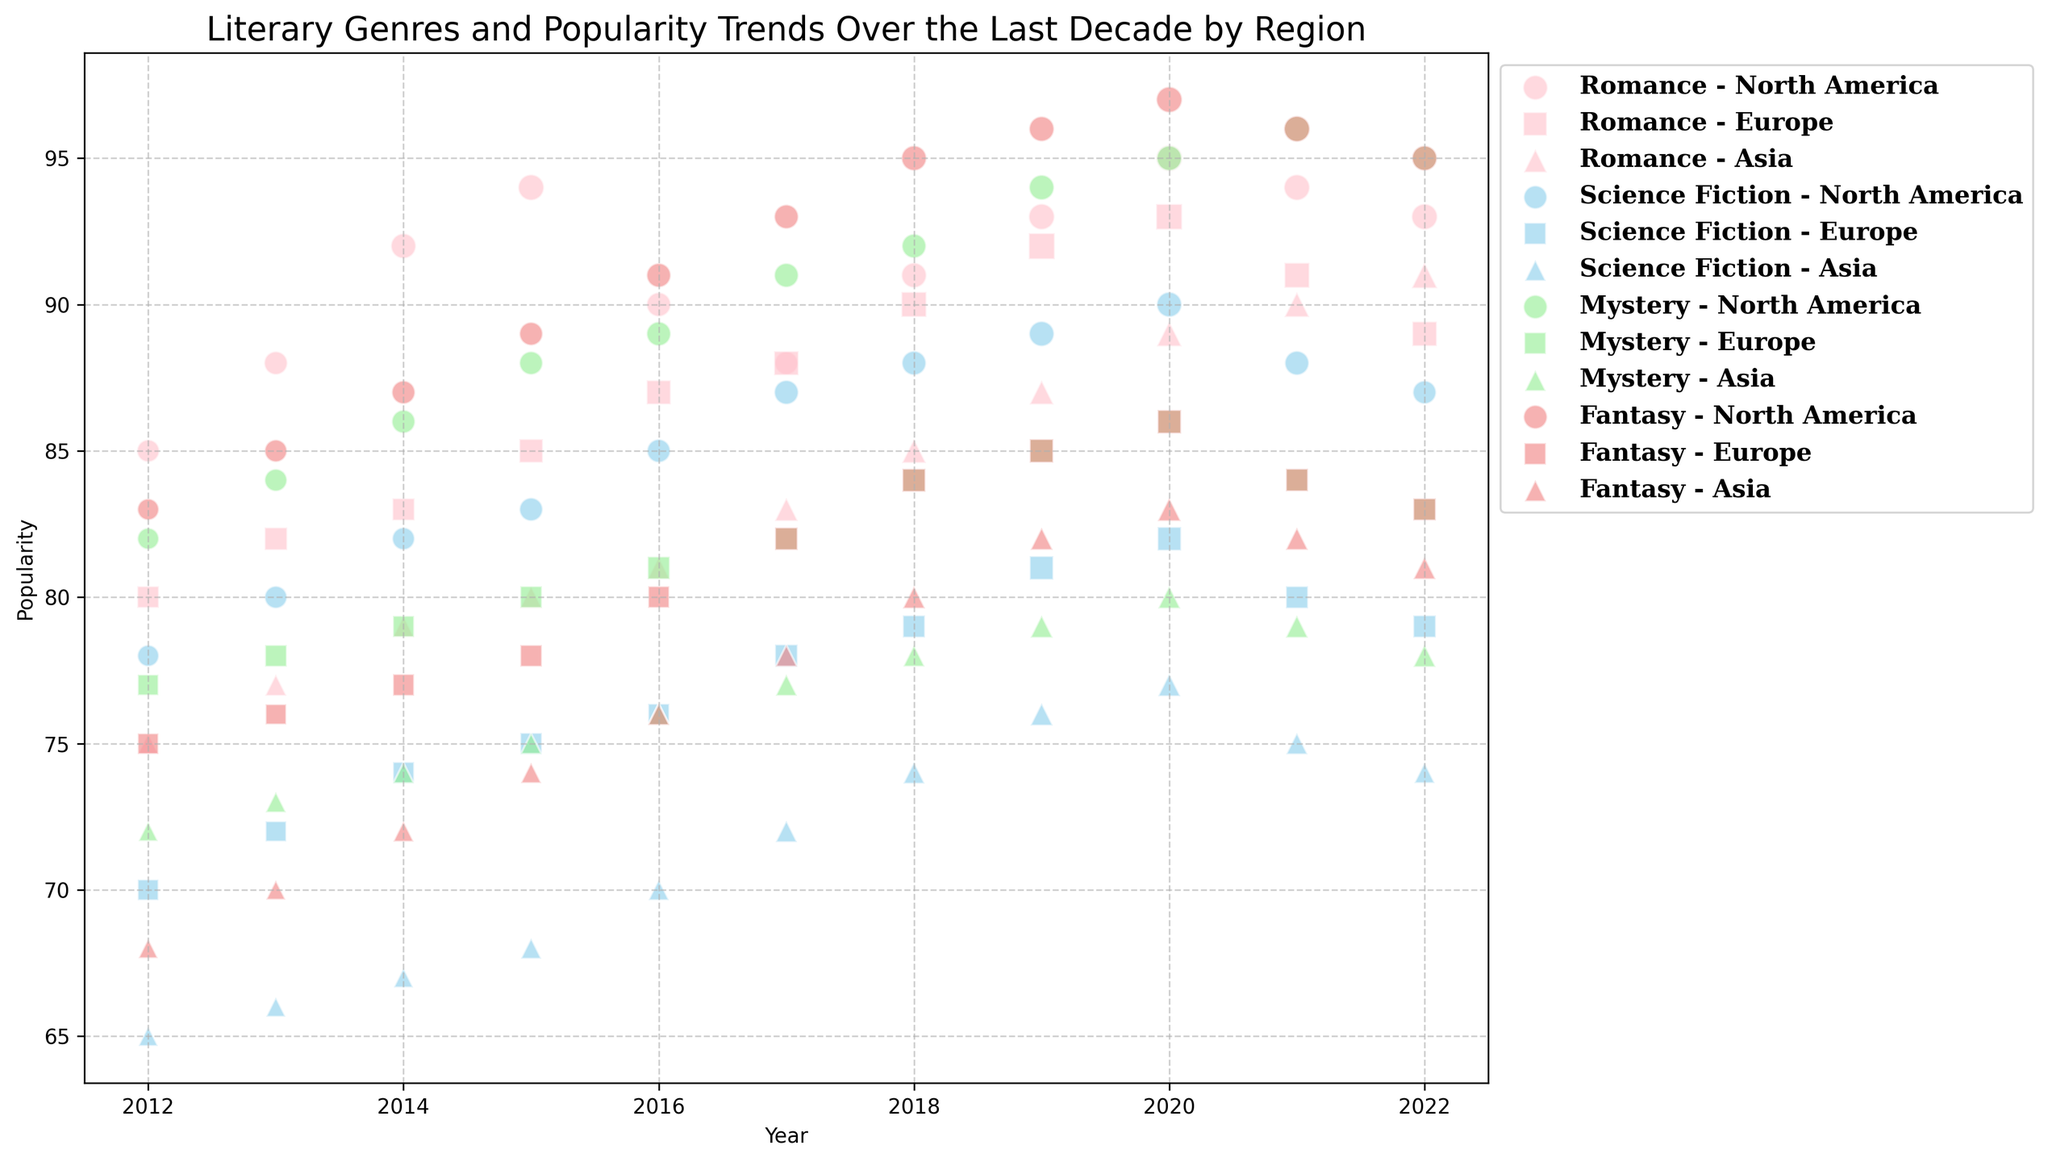Which region had the highest popularity for Fantasy in 2020? Looking at the bubbles for Fantasy in 2020, North America's bubble appears the highest on the y-axis, indicating it had the highest popularity.
Answer: North America Between 2015 and 2020, did the popularity of Romance in Europe increase or decrease? Track the Romance bubbles for Europe during the years 2015-2020. The y-axis values go from 85 in 2015 to 93 in 2020, showing an increase.
Answer: Increase Compare the popularity of Science Fiction in Asia and Europe in 2022. Which region had higher popularity? Find the Science Fiction bubbles for Asia and Europe in 2022. The y-value for Asia is 74, while for Europe, it is 79. Therefore, Europe had higher popularity.
Answer: Europe What's the average popularity of Mystery in North America from 2020 to 2022? Find the Mystery bubbles for North America from 2020 to 2022. The popularity values are 95, 96, and 95. Average them: (95 + 96 + 95) / 3 = 95.33
Answer: 95.33 Which genre had the smallest size bubble in Asia in 2016? Compare the sizes of the bubbles for different genres in Asia in 2016. The smallest size is seen for Science Fiction (1.0).
Answer: Science Fiction Did the popularity trend of Science Fiction in North America increase, decrease, or stay the same from 2018 to 2022? Track the Science Fiction bubbles' y-values for North America from 2018 to 2022. The values go from 88 to 87, therefore, the trend decreased.
Answer: Decrease Which genre in Europe had the most stable popularity trend from 2012 to 2022? For each genre in Europe, check the changes in y-values from 2012 to 2022. Romance values vary the least, going from 80 to 89 with relatively small yearly changes.
Answer: Romance What is the difference in popularity of Fantasy between North America and Asia in 2022? Compare the y-values of Fantasy in North America (95) and Asia (81) in 2022. Difference: 95 - 81 = 14
Answer: 14 What color represents the Fantasy genre in the chart? Look at the legend and the bubbles to identify the color used for Fantasy. The bubbles for Fantasy are light coral.
Answer: Light coral Between Romance and Mystery, which genre had a higher popularity in Europe in 2016? Compare the y-values of Romance (87) and Mystery (81) in Europe in 2016. Romance has a higher popularity.
Answer: Romance 